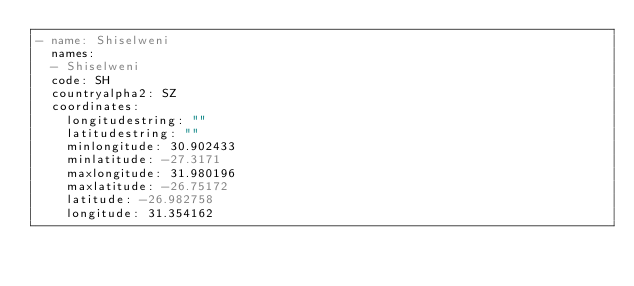<code> <loc_0><loc_0><loc_500><loc_500><_YAML_>- name: Shiselweni
  names:
  - Shiselweni
  code: SH
  countryalpha2: SZ
  coordinates:
    longitudestring: ""
    latitudestring: ""
    minlongitude: 30.902433
    minlatitude: -27.3171
    maxlongitude: 31.980196
    maxlatitude: -26.75172
    latitude: -26.982758
    longitude: 31.354162</code> 